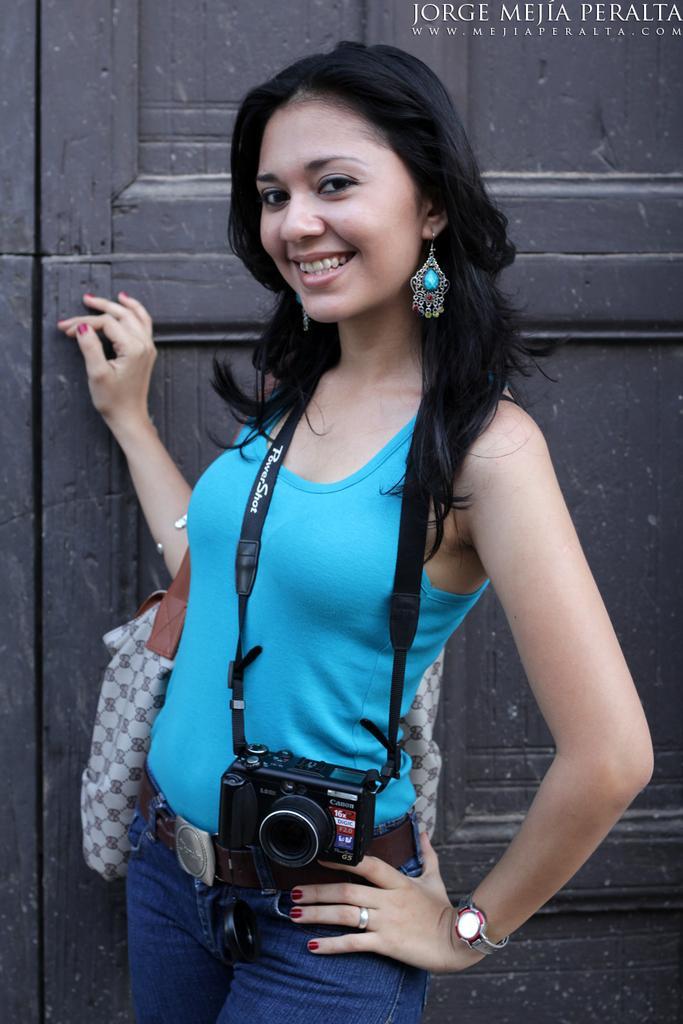Describe this image in one or two sentences. In this picture I can see in the middle a girl is wearing the dress and a camera, she is smiling, in the top right hand side there is the text. 